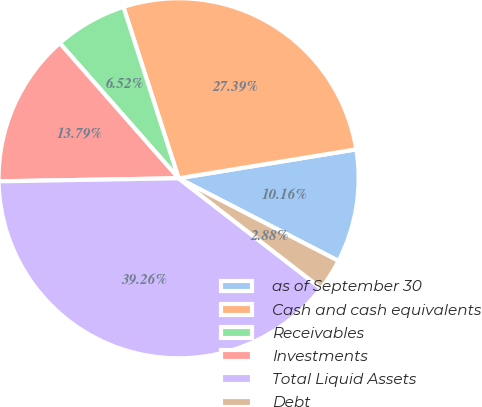Convert chart. <chart><loc_0><loc_0><loc_500><loc_500><pie_chart><fcel>as of September 30<fcel>Cash and cash equivalents<fcel>Receivables<fcel>Investments<fcel>Total Liquid Assets<fcel>Debt<nl><fcel>10.16%<fcel>27.39%<fcel>6.52%<fcel>13.79%<fcel>39.26%<fcel>2.88%<nl></chart> 